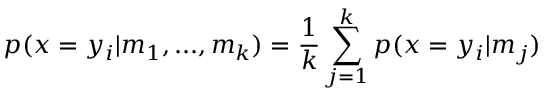Convert formula to latex. <formula><loc_0><loc_0><loc_500><loc_500>p ( x = y _ { i } | m _ { 1 } , \dots , m _ { k } ) = \frac { 1 } { k } \sum _ { j = 1 } ^ { k } p ( x = y _ { i } | m _ { j } )</formula> 